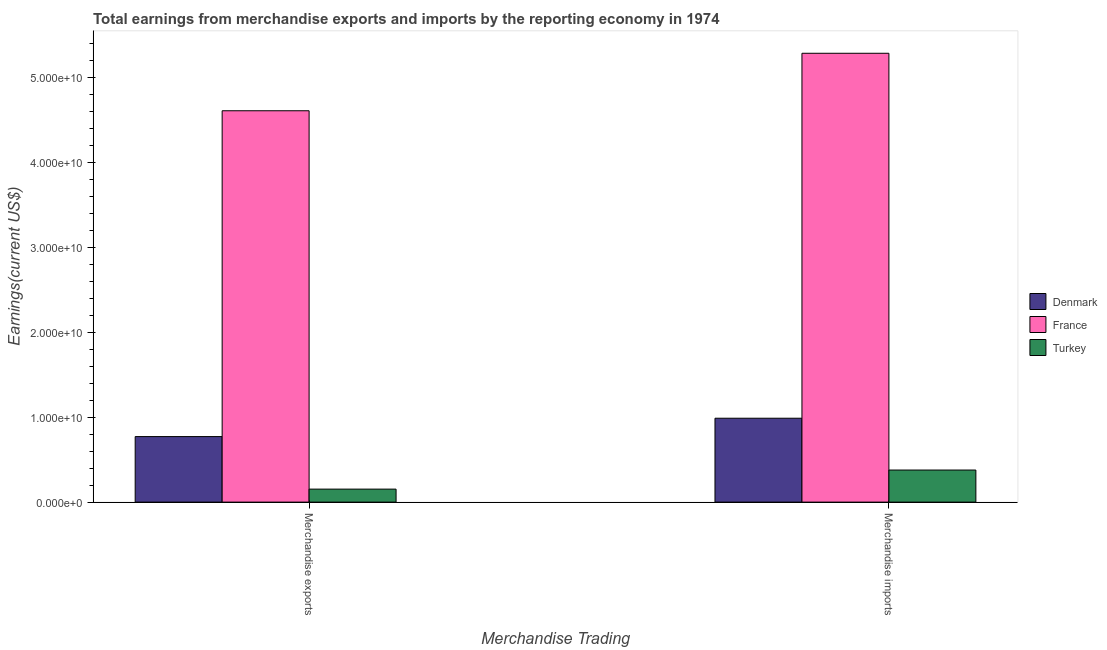How many groups of bars are there?
Provide a succinct answer. 2. Are the number of bars on each tick of the X-axis equal?
Provide a succinct answer. Yes. What is the earnings from merchandise imports in Turkey?
Keep it short and to the point. 3.78e+09. Across all countries, what is the maximum earnings from merchandise imports?
Offer a very short reply. 5.28e+1. Across all countries, what is the minimum earnings from merchandise imports?
Provide a succinct answer. 3.78e+09. What is the total earnings from merchandise exports in the graph?
Your response must be concise. 5.53e+1. What is the difference between the earnings from merchandise imports in Denmark and that in France?
Give a very brief answer. -4.30e+1. What is the difference between the earnings from merchandise exports in France and the earnings from merchandise imports in Turkey?
Offer a terse response. 4.23e+1. What is the average earnings from merchandise exports per country?
Provide a succinct answer. 1.84e+1. What is the difference between the earnings from merchandise exports and earnings from merchandise imports in France?
Provide a succinct answer. -6.77e+09. In how many countries, is the earnings from merchandise imports greater than 8000000000 US$?
Give a very brief answer. 2. What is the ratio of the earnings from merchandise exports in Denmark to that in Turkey?
Keep it short and to the point. 5.04. Is the earnings from merchandise exports in Denmark less than that in France?
Your response must be concise. Yes. In how many countries, is the earnings from merchandise exports greater than the average earnings from merchandise exports taken over all countries?
Make the answer very short. 1. How many countries are there in the graph?
Keep it short and to the point. 3. What is the difference between two consecutive major ticks on the Y-axis?
Your answer should be very brief. 1.00e+1. Does the graph contain grids?
Keep it short and to the point. No. What is the title of the graph?
Your answer should be compact. Total earnings from merchandise exports and imports by the reporting economy in 1974. What is the label or title of the X-axis?
Ensure brevity in your answer.  Merchandise Trading. What is the label or title of the Y-axis?
Provide a short and direct response. Earnings(current US$). What is the Earnings(current US$) in Denmark in Merchandise exports?
Your response must be concise. 7.72e+09. What is the Earnings(current US$) in France in Merchandise exports?
Provide a short and direct response. 4.61e+1. What is the Earnings(current US$) of Turkey in Merchandise exports?
Your answer should be compact. 1.53e+09. What is the Earnings(current US$) of Denmark in Merchandise imports?
Your answer should be compact. 9.88e+09. What is the Earnings(current US$) of France in Merchandise imports?
Your response must be concise. 5.28e+1. What is the Earnings(current US$) of Turkey in Merchandise imports?
Keep it short and to the point. 3.78e+09. Across all Merchandise Trading, what is the maximum Earnings(current US$) in Denmark?
Your response must be concise. 9.88e+09. Across all Merchandise Trading, what is the maximum Earnings(current US$) of France?
Offer a very short reply. 5.28e+1. Across all Merchandise Trading, what is the maximum Earnings(current US$) of Turkey?
Offer a terse response. 3.78e+09. Across all Merchandise Trading, what is the minimum Earnings(current US$) of Denmark?
Your answer should be compact. 7.72e+09. Across all Merchandise Trading, what is the minimum Earnings(current US$) in France?
Make the answer very short. 4.61e+1. Across all Merchandise Trading, what is the minimum Earnings(current US$) of Turkey?
Your answer should be compact. 1.53e+09. What is the total Earnings(current US$) in Denmark in the graph?
Your response must be concise. 1.76e+1. What is the total Earnings(current US$) in France in the graph?
Provide a succinct answer. 9.89e+1. What is the total Earnings(current US$) of Turkey in the graph?
Your response must be concise. 5.31e+09. What is the difference between the Earnings(current US$) in Denmark in Merchandise exports and that in Merchandise imports?
Your response must be concise. -2.16e+09. What is the difference between the Earnings(current US$) in France in Merchandise exports and that in Merchandise imports?
Offer a terse response. -6.77e+09. What is the difference between the Earnings(current US$) in Turkey in Merchandise exports and that in Merchandise imports?
Ensure brevity in your answer.  -2.24e+09. What is the difference between the Earnings(current US$) of Denmark in Merchandise exports and the Earnings(current US$) of France in Merchandise imports?
Ensure brevity in your answer.  -4.51e+1. What is the difference between the Earnings(current US$) of Denmark in Merchandise exports and the Earnings(current US$) of Turkey in Merchandise imports?
Offer a terse response. 3.94e+09. What is the difference between the Earnings(current US$) of France in Merchandise exports and the Earnings(current US$) of Turkey in Merchandise imports?
Your answer should be very brief. 4.23e+1. What is the average Earnings(current US$) in Denmark per Merchandise Trading?
Give a very brief answer. 8.80e+09. What is the average Earnings(current US$) in France per Merchandise Trading?
Your answer should be very brief. 4.95e+1. What is the average Earnings(current US$) of Turkey per Merchandise Trading?
Make the answer very short. 2.65e+09. What is the difference between the Earnings(current US$) of Denmark and Earnings(current US$) of France in Merchandise exports?
Ensure brevity in your answer.  -3.84e+1. What is the difference between the Earnings(current US$) of Denmark and Earnings(current US$) of Turkey in Merchandise exports?
Offer a very short reply. 6.18e+09. What is the difference between the Earnings(current US$) in France and Earnings(current US$) in Turkey in Merchandise exports?
Offer a terse response. 4.45e+1. What is the difference between the Earnings(current US$) in Denmark and Earnings(current US$) in France in Merchandise imports?
Your answer should be very brief. -4.30e+1. What is the difference between the Earnings(current US$) in Denmark and Earnings(current US$) in Turkey in Merchandise imports?
Ensure brevity in your answer.  6.10e+09. What is the difference between the Earnings(current US$) in France and Earnings(current US$) in Turkey in Merchandise imports?
Your response must be concise. 4.91e+1. What is the ratio of the Earnings(current US$) in Denmark in Merchandise exports to that in Merchandise imports?
Make the answer very short. 0.78. What is the ratio of the Earnings(current US$) in France in Merchandise exports to that in Merchandise imports?
Your answer should be very brief. 0.87. What is the ratio of the Earnings(current US$) of Turkey in Merchandise exports to that in Merchandise imports?
Your answer should be very brief. 0.41. What is the difference between the highest and the second highest Earnings(current US$) of Denmark?
Provide a succinct answer. 2.16e+09. What is the difference between the highest and the second highest Earnings(current US$) of France?
Keep it short and to the point. 6.77e+09. What is the difference between the highest and the second highest Earnings(current US$) in Turkey?
Offer a terse response. 2.24e+09. What is the difference between the highest and the lowest Earnings(current US$) in Denmark?
Ensure brevity in your answer.  2.16e+09. What is the difference between the highest and the lowest Earnings(current US$) in France?
Your answer should be compact. 6.77e+09. What is the difference between the highest and the lowest Earnings(current US$) in Turkey?
Make the answer very short. 2.24e+09. 